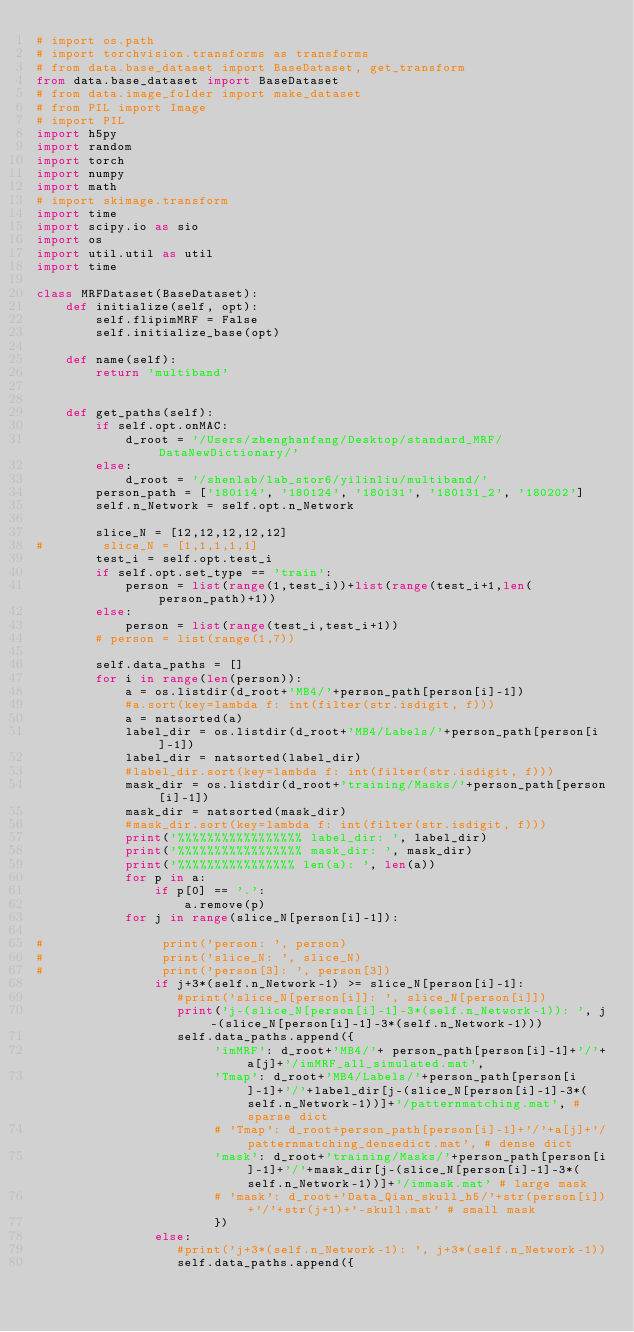Convert code to text. <code><loc_0><loc_0><loc_500><loc_500><_Python_># import os.path
# import torchvision.transforms as transforms
# from data.base_dataset import BaseDataset, get_transform
from data.base_dataset import BaseDataset
# from data.image_folder import make_dataset
# from PIL import Image
# import PIL
import h5py
import random
import torch
import numpy
import math
# import skimage.transform
import time
import scipy.io as sio
import os
import util.util as util
import time

class MRFDataset(BaseDataset):
    def initialize(self, opt):
        self.flipimMRF = False
        self.initialize_base(opt)

    def name(self):
        return 'multiband'
    

    def get_paths(self):
        if self.opt.onMAC:
            d_root = '/Users/zhenghanfang/Desktop/standard_MRF/DataNewDictionary/'
        else:
            d_root = '/shenlab/lab_stor6/yilinliu/multiband/'
        person_path = ['180114', '180124', '180131', '180131_2', '180202']
        self.n_Network = self.opt.n_Network
     
        slice_N = [12,12,12,12,12]
#        slice_N = [1,1,1,1,1]
        test_i = self.opt.test_i
        if self.opt.set_type == 'train':
            person = list(range(1,test_i))+list(range(test_i+1,len(person_path)+1))
        else:
            person = list(range(test_i,test_i+1))
        # person = list(range(1,7))

        self.data_paths = []
        for i in range(len(person)):
            a = os.listdir(d_root+'MB4/'+person_path[person[i]-1])
            #a.sort(key=lambda f: int(filter(str.isdigit, f)))
            a = natsorted(a)
            label_dir = os.listdir(d_root+'MB4/Labels/'+person_path[person[i]-1])
            label_dir = natsorted(label_dir)
            #label_dir.sort(key=lambda f: int(filter(str.isdigit, f)))
            mask_dir = os.listdir(d_root+'training/Masks/'+person_path[person[i]-1])
            mask_dir = natsorted(mask_dir)
            #mask_dir.sort(key=lambda f: int(filter(str.isdigit, f)))
            print('%%%%%%%%%%%%%%%%% label_dir: ', label_dir)
            print('%%%%%%%%%%%%%%%%% mask_dir: ', mask_dir)
            print('%%%%%%%%%%%%%%%% len(a): ', len(a))
            for p in a:
                if p[0] == '.':
                    a.remove(p)
            for j in range(slice_N[person[i]-1]):
      
#                print('person: ', person)
#                print('slice_N: ', slice_N)
#                print('person[3]: ', person[3])
                if j+3*(self.n_Network-1) >= slice_N[person[i]-1]:
                   #print('slice_N[person[i]]: ', slice_N[person[i]])
                   print('j-(slice_N[person[i]-1]-3*(self.n_Network-1)): ', j-(slice_N[person[i]-1]-3*(self.n_Network-1)))
                   self.data_paths.append({
                        'imMRF': d_root+'MB4/'+ person_path[person[i]-1]+'/'+a[j]+'/imMRF_all_simulated.mat',
                        'Tmap': d_root+'MB4/Labels/'+person_path[person[i]-1]+'/'+label_dir[j-(slice_N[person[i]-1]-3*(self.n_Network-1))]+'/patternmatching.mat', # sparse dict
                        # 'Tmap': d_root+person_path[person[i]-1]+'/'+a[j]+'/patternmatching_densedict.mat', # dense dict
                        'mask': d_root+'training/Masks/'+person_path[person[i]-1]+'/'+mask_dir[j-(slice_N[person[i]-1]-3*(self.n_Network-1))]+'/immask.mat' # large mask
                        # 'mask': d_root+'Data_Qian_skull_h5/'+str(person[i])+'/'+str(j+1)+'-skull.mat' # small mask
                        })
                else:
                   #print('j+3*(self.n_Network-1): ', j+3*(self.n_Network-1))
                   self.data_paths.append({</code> 